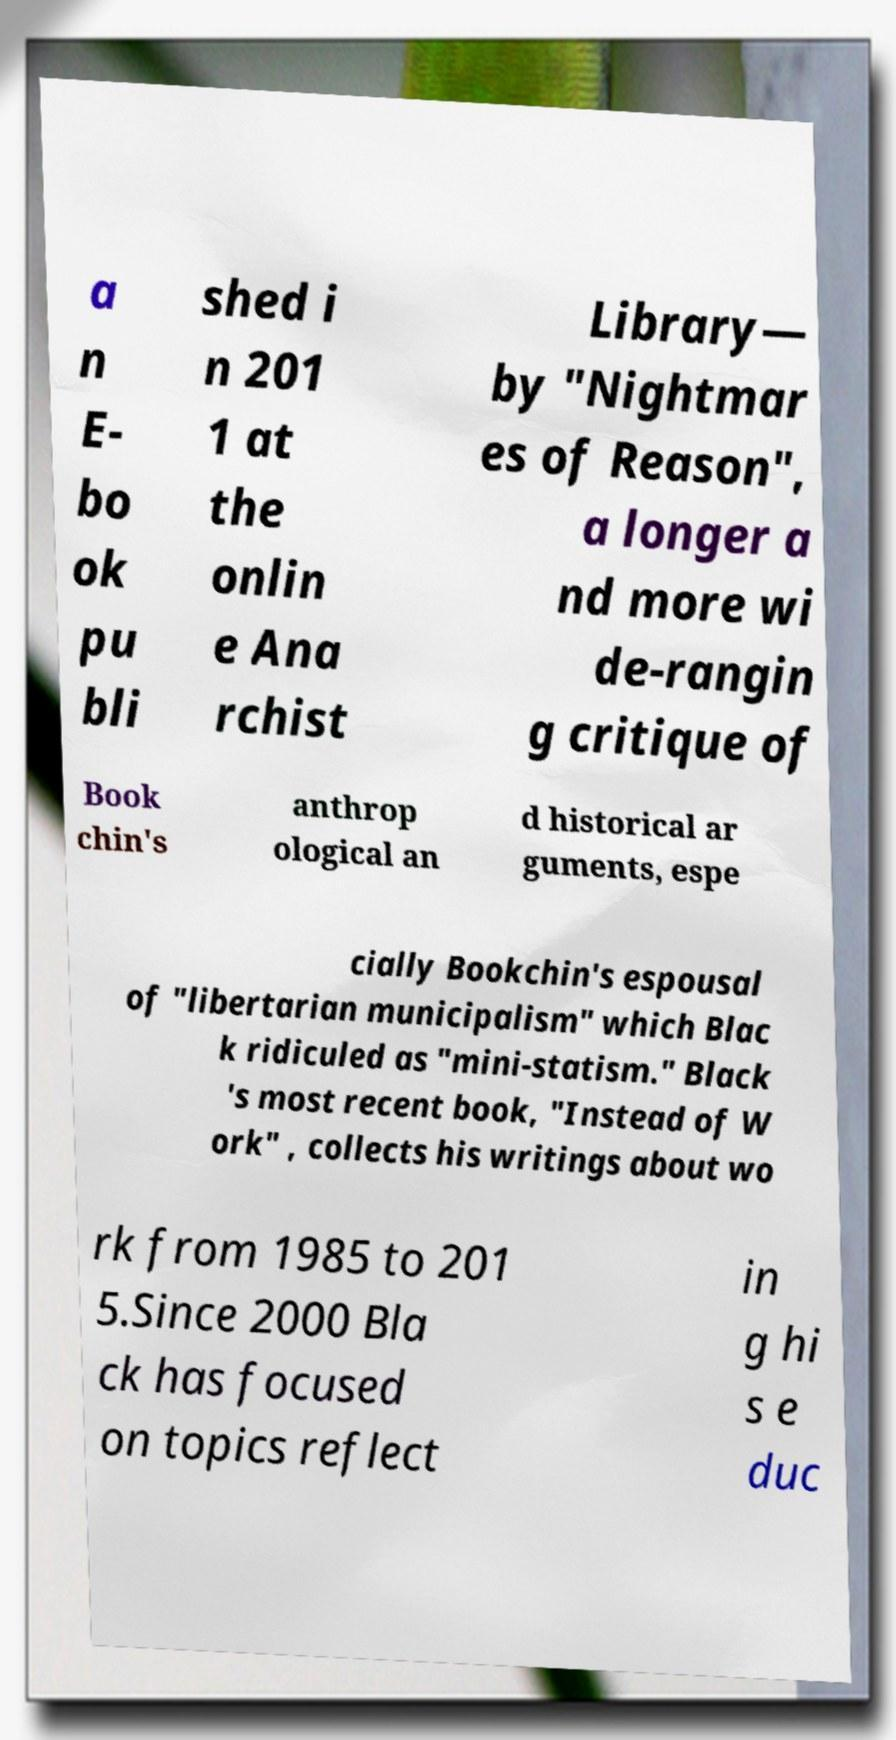Can you read and provide the text displayed in the image?This photo seems to have some interesting text. Can you extract and type it out for me? a n E- bo ok pu bli shed i n 201 1 at the onlin e Ana rchist Library— by "Nightmar es of Reason", a longer a nd more wi de-rangin g critique of Book chin's anthrop ological an d historical ar guments, espe cially Bookchin's espousal of "libertarian municipalism" which Blac k ridiculed as "mini-statism." Black 's most recent book, "Instead of W ork" , collects his writings about wo rk from 1985 to 201 5.Since 2000 Bla ck has focused on topics reflect in g hi s e duc 